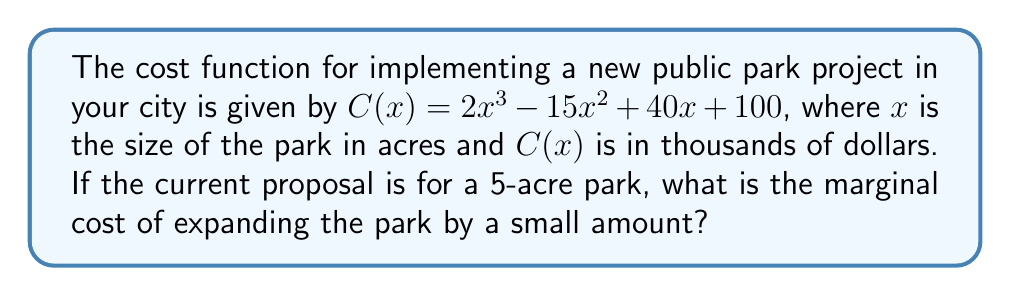Could you help me with this problem? To find the marginal cost, we need to calculate the derivative of the cost function $C(x)$ and then evaluate it at $x = 5$. Here's the step-by-step process:

1) The cost function is $C(x) = 2x^3 - 15x^2 + 40x + 100$

2) To find the derivative $C'(x)$, we apply the power rule and constant rule:
   $$C'(x) = 6x^2 - 30x + 40$$

3) This derivative function $C'(x)$ represents the marginal cost.

4) To find the marginal cost at $x = 5$, we substitute this value into $C'(x)$:
   $$C'(5) = 6(5)^2 - 30(5) + 40$$

5) Simplify:
   $$C'(5) = 6(25) - 150 + 40 = 150 - 150 + 40 = 40$$

6) Therefore, the marginal cost when the park size is 5 acres is 40 thousand dollars per acre.
Answer: $40,000 per acre 